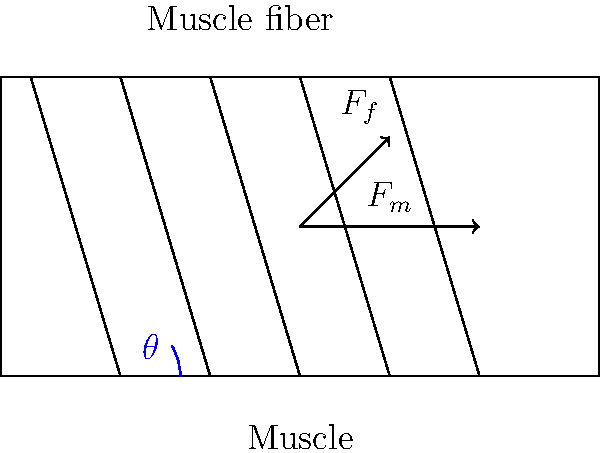Consider the schematic representation of a pennate muscle above. If the pennation angle is denoted by $\theta$ and the force generated by an individual muscle fiber is $F_f$, derive a mathematical expression for the total muscle force $F_m$ in terms of $F_f$, $\theta$, and the number of muscle fibers $n$. To derive the expression for total muscle force $F_m$, we'll follow these steps:

1) First, consider a single muscle fiber. The force it generates ($F_f$) is at an angle $\theta$ to the direction of the overall muscle force ($F_m$).

2) The component of the fiber force in the direction of $F_m$ is given by:
   $$F_{f,\parallel} = F_f \cos(\theta)$$

3) This is the contribution of a single fiber to the total muscle force.

4) Assuming there are $n$ identical fibers, each contributing equally, the total muscle force will be the sum of all these components:
   $$F_m = n F_f \cos(\theta)$$

5) This equation represents the mathematical relationship between the total muscle force, individual fiber force, pennation angle, and number of fibers.

6) It's worth noting that this model assumes all fibers are identical and arranged at the same angle, which is a simplification of real muscle architecture.

7) The equation demonstrates that as the pennation angle increases, the effective force in the muscle's line of action decreases (as $\cos(\theta)$ decreases), but this can be compensated by an increase in the number of fibers that can fit in the muscle volume.
Answer: $F_m = n F_f \cos(\theta)$ 